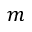<formula> <loc_0><loc_0><loc_500><loc_500>m</formula> 